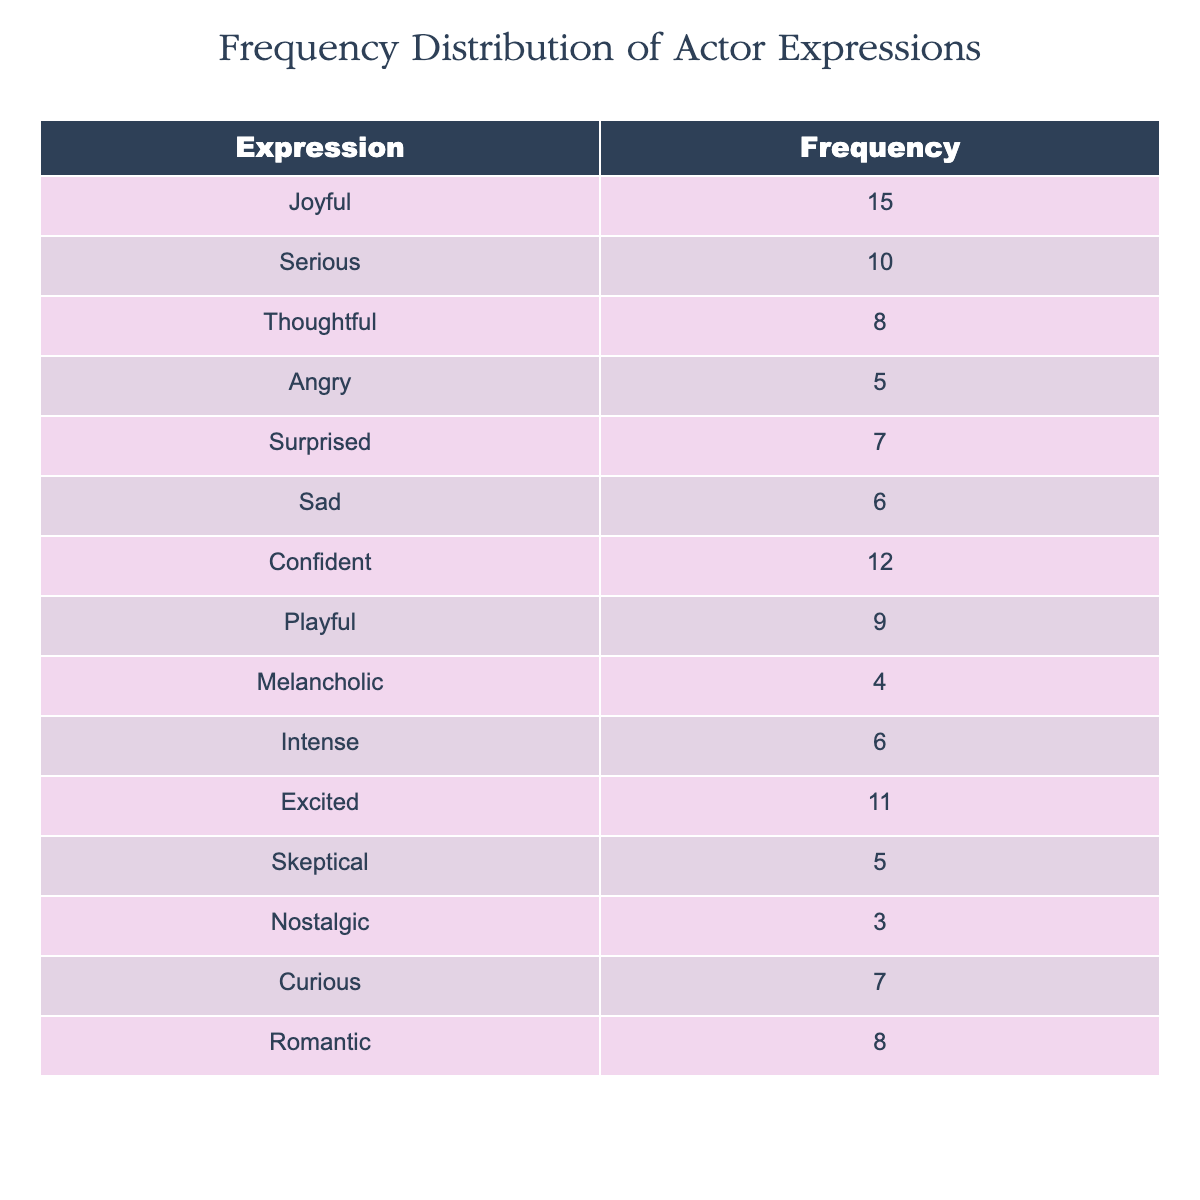What expression has the highest frequency in the table? The expression "Joyful" has a frequency of 15, which is the highest compared to other expressions listed.
Answer: Joyful Which expression is expressed more frequently, "Sad" or "Surprised"? The "Sad" expression has a frequency of 6, while "Surprised" has a frequency of 7. Thus, "Surprised" is expressed more frequently.
Answer: Surprised What is the total frequency of all expressions captured in the headshots? To find the total frequency, we sum all the individual frequencies: 15 + 10 + 8 + 5 + 7 + 6 + 12 + 9 + 4 + 6 + 11 + 5 + 3 + 7 + 8 =  88.
Answer: 88 Is there an expression that has a frequency of exactly 5? Yes, both "Angry" and "Skeptical" have a frequency of 5 as noted in the table.
Answer: Yes What is the average frequency of all captured expressions? To calculate the average, we add the frequencies (88) and divide by the total number of expressions (15): 88 / 15 = 5.87.
Answer: 5.87 Which expressions have a frequency of 10 or higher? The expressions are "Joyful" (15), "Confident" (12), "Excited" (11), and "Serious" (10). These expressions list frequencies that meet or exceed 10.
Answer: Joyful, Confident, Excited, Serious What is the difference in frequency between "Joyful" and "Melancholic"? The frequency of "Joyful" is 15, and for "Melancholic," it is 4. To find the difference, we subtract: 15 - 4 = 11.
Answer: 11 How many expressions have a frequency of less than 6? The expressions with a frequency of less than 6 are "Melancholic" (4), "Skeptical" (5), and "Sad" (6 does not count). That gives us a total of 3 expressions.
Answer: 3 Do the frequencies of "Thoughtful" and "Romantic" add up to more than 15? The frequency for "Thoughtful" is 8 and for "Romantic" is 8. Adding these gives us: 8 + 8 = 16, which is more than 15.
Answer: Yes 